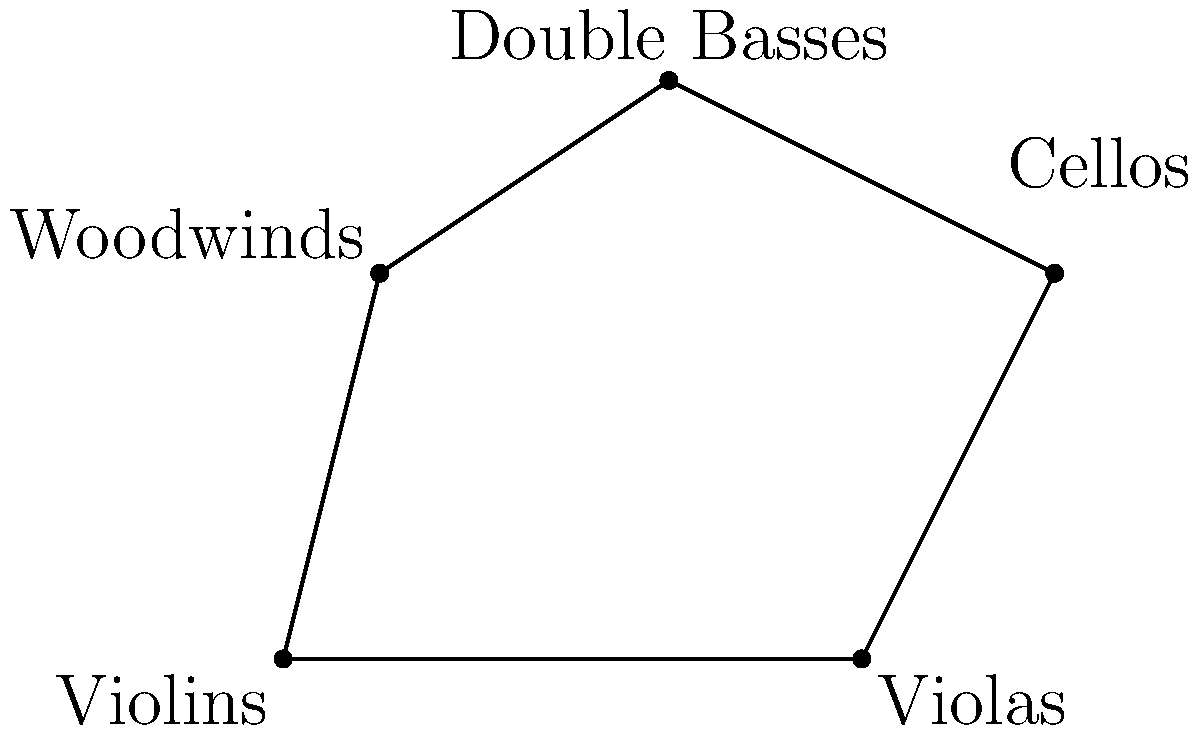In a prestigious symphony orchestra, the positions of different instrument sections are represented by the vertices of a polygon on a coordinate plane. The violins are at (0,0), violas at (6,0), cellos at (8,4), double basses at (4,6), and woodwinds at (1,4). Calculate the area of the polygon formed by connecting these positions, demonstrating the harmonious spatial arrangement of a proper orchestra. To find the area of this irregular polygon, we can use the Shoelace formula (also known as the surveyor's formula). The steps are as follows:

1) First, list the coordinates in order, including the first point at the end to close the polygon:
   (0,0), (6,0), (8,4), (4,6), (1,4), (0,0)

2) Apply the Shoelace formula:
   Area = $\frac{1}{2}|[(x_1y_2 + x_2y_3 + ... + x_ny_1) - (y_1x_2 + y_2x_3 + ... + y_nx_1)]|$

3) Substituting the values:
   Area = $\frac{1}{2}|[(0 \cdot 0 + 6 \cdot 4 + 8 \cdot 6 + 4 \cdot 4 + 1 \cdot 0) - (0 \cdot 6 + 0 \cdot 8 + 4 \cdot 4 + 6 \cdot 1 + 4 \cdot 0)]|$

4) Simplify:
   Area = $\frac{1}{2}|[(0 + 24 + 48 + 16 + 0) - (0 + 0 + 16 + 6 + 0)]|$
   Area = $\frac{1}{2}|[88 - 22]|$
   Area = $\frac{1}{2}[66]$
   Area = 33

Therefore, the area of the polygon representing the orchestra layout is 33 square units.
Answer: 33 square units 